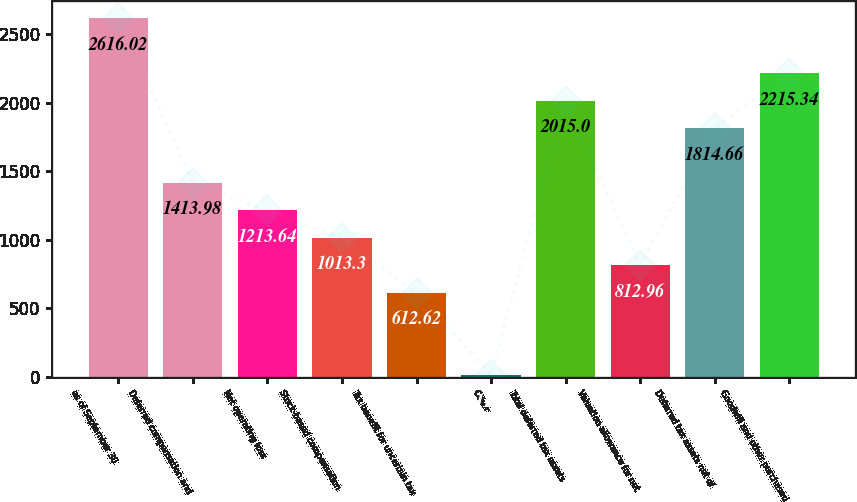Convert chart to OTSL. <chart><loc_0><loc_0><loc_500><loc_500><bar_chart><fcel>as of September 30<fcel>Deferred compensation and<fcel>Net operating loss<fcel>Stock-based compensation<fcel>Tax benefit for uncertain tax<fcel>Other<fcel>Total deferred tax assets<fcel>Valuation allowance for net<fcel>Deferred tax assets net of<fcel>Goodwill and other purchased<nl><fcel>2616.02<fcel>1413.98<fcel>1213.64<fcel>1013.3<fcel>612.62<fcel>11.6<fcel>2015<fcel>812.96<fcel>1814.66<fcel>2215.34<nl></chart> 